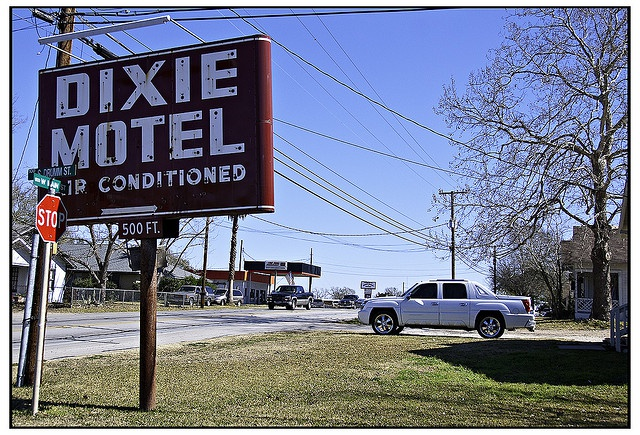Describe the objects in this image and their specific colors. I can see car in white, black, gray, and lavender tones, stop sign in white, red, black, and brown tones, truck in white, black, gray, navy, and darkgray tones, car in white, black, gray, navy, and darkgray tones, and truck in white, black, gray, darkgray, and lavender tones in this image. 